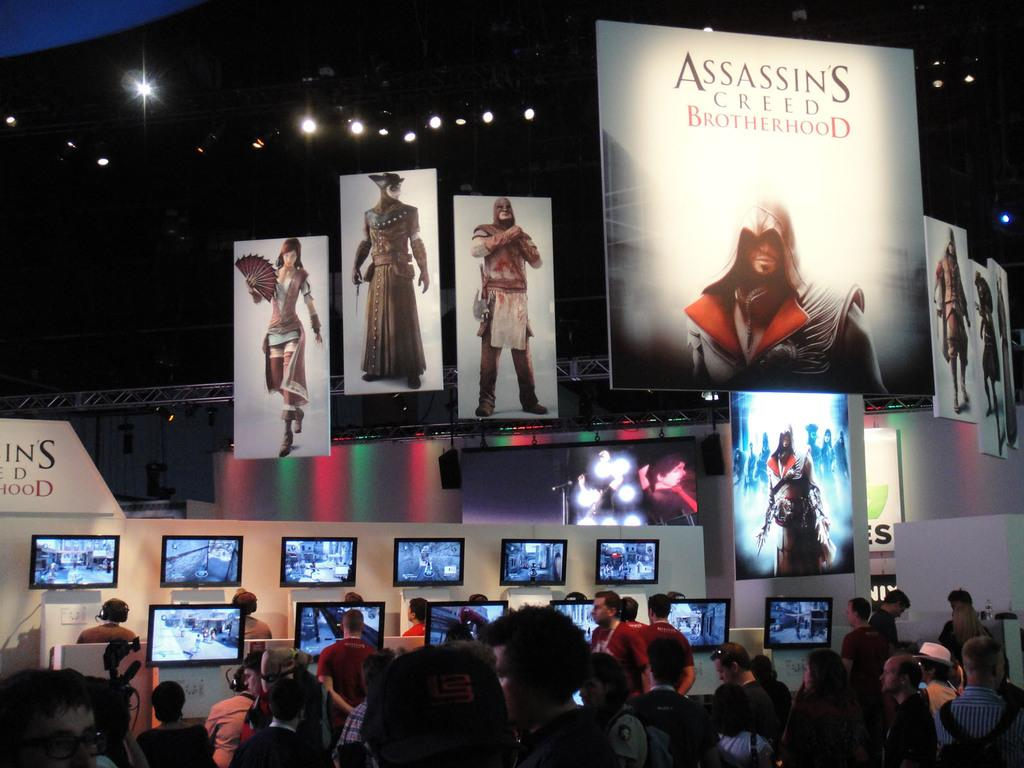What are the people in the image doing? The people in the image are standing and watching televisions. What can be seen at the top of the image? There are posters and screens with lights at the top of the image. What type of shame is depicted in the image? There is no shame depicted in the image; it features people watching televisions and posters and screens with lights. 